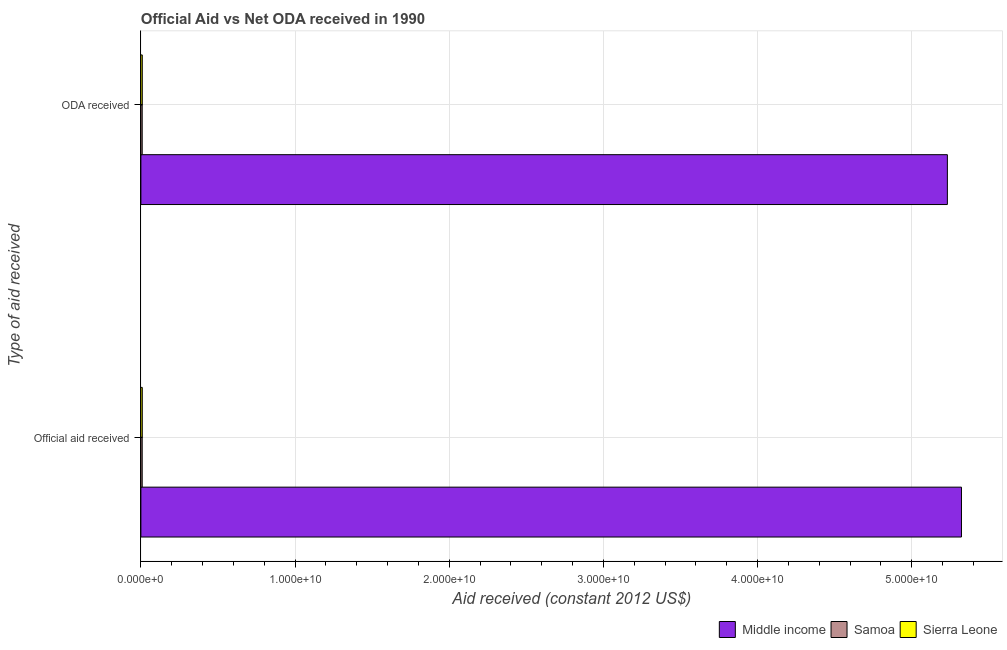How many groups of bars are there?
Give a very brief answer. 2. How many bars are there on the 1st tick from the bottom?
Your answer should be very brief. 3. What is the label of the 2nd group of bars from the top?
Your response must be concise. Official aid received. What is the official aid received in Sierra Leone?
Keep it short and to the point. 9.17e+07. Across all countries, what is the maximum official aid received?
Offer a very short reply. 5.32e+1. Across all countries, what is the minimum official aid received?
Provide a short and direct response. 8.48e+07. In which country was the oda received maximum?
Give a very brief answer. Middle income. In which country was the official aid received minimum?
Your answer should be compact. Samoa. What is the total oda received in the graph?
Provide a short and direct response. 5.25e+1. What is the difference between the oda received in Middle income and that in Samoa?
Your answer should be compact. 5.22e+1. What is the difference between the official aid received in Middle income and the oda received in Samoa?
Ensure brevity in your answer.  5.31e+1. What is the average official aid received per country?
Offer a very short reply. 1.78e+1. What is the difference between the oda received and official aid received in Middle income?
Ensure brevity in your answer.  -9.14e+08. In how many countries, is the official aid received greater than 28000000000 US$?
Keep it short and to the point. 1. What is the ratio of the official aid received in Samoa to that in Middle income?
Make the answer very short. 0. Is the official aid received in Middle income less than that in Samoa?
Provide a succinct answer. No. In how many countries, is the oda received greater than the average oda received taken over all countries?
Offer a very short reply. 1. What does the 3rd bar from the top in ODA received represents?
Make the answer very short. Middle income. What does the 3rd bar from the bottom in Official aid received represents?
Keep it short and to the point. Sierra Leone. What is the difference between two consecutive major ticks on the X-axis?
Your response must be concise. 1.00e+1. Where does the legend appear in the graph?
Your answer should be compact. Bottom right. What is the title of the graph?
Your answer should be compact. Official Aid vs Net ODA received in 1990 . What is the label or title of the X-axis?
Give a very brief answer. Aid received (constant 2012 US$). What is the label or title of the Y-axis?
Your response must be concise. Type of aid received. What is the Aid received (constant 2012 US$) of Middle income in Official aid received?
Make the answer very short. 5.32e+1. What is the Aid received (constant 2012 US$) of Samoa in Official aid received?
Keep it short and to the point. 8.48e+07. What is the Aid received (constant 2012 US$) in Sierra Leone in Official aid received?
Your response must be concise. 9.17e+07. What is the Aid received (constant 2012 US$) in Middle income in ODA received?
Ensure brevity in your answer.  5.23e+1. What is the Aid received (constant 2012 US$) of Samoa in ODA received?
Your answer should be compact. 8.48e+07. What is the Aid received (constant 2012 US$) in Sierra Leone in ODA received?
Make the answer very short. 9.17e+07. Across all Type of aid received, what is the maximum Aid received (constant 2012 US$) of Middle income?
Offer a terse response. 5.32e+1. Across all Type of aid received, what is the maximum Aid received (constant 2012 US$) of Samoa?
Ensure brevity in your answer.  8.48e+07. Across all Type of aid received, what is the maximum Aid received (constant 2012 US$) of Sierra Leone?
Your response must be concise. 9.17e+07. Across all Type of aid received, what is the minimum Aid received (constant 2012 US$) of Middle income?
Keep it short and to the point. 5.23e+1. Across all Type of aid received, what is the minimum Aid received (constant 2012 US$) of Samoa?
Provide a short and direct response. 8.48e+07. Across all Type of aid received, what is the minimum Aid received (constant 2012 US$) of Sierra Leone?
Provide a succinct answer. 9.17e+07. What is the total Aid received (constant 2012 US$) of Middle income in the graph?
Keep it short and to the point. 1.06e+11. What is the total Aid received (constant 2012 US$) of Samoa in the graph?
Your answer should be very brief. 1.70e+08. What is the total Aid received (constant 2012 US$) in Sierra Leone in the graph?
Keep it short and to the point. 1.83e+08. What is the difference between the Aid received (constant 2012 US$) of Middle income in Official aid received and that in ODA received?
Provide a succinct answer. 9.14e+08. What is the difference between the Aid received (constant 2012 US$) in Samoa in Official aid received and that in ODA received?
Your answer should be compact. 0. What is the difference between the Aid received (constant 2012 US$) in Sierra Leone in Official aid received and that in ODA received?
Give a very brief answer. 0. What is the difference between the Aid received (constant 2012 US$) of Middle income in Official aid received and the Aid received (constant 2012 US$) of Samoa in ODA received?
Provide a short and direct response. 5.31e+1. What is the difference between the Aid received (constant 2012 US$) of Middle income in Official aid received and the Aid received (constant 2012 US$) of Sierra Leone in ODA received?
Offer a very short reply. 5.31e+1. What is the difference between the Aid received (constant 2012 US$) in Samoa in Official aid received and the Aid received (constant 2012 US$) in Sierra Leone in ODA received?
Ensure brevity in your answer.  -6.94e+06. What is the average Aid received (constant 2012 US$) in Middle income per Type of aid received?
Keep it short and to the point. 5.28e+1. What is the average Aid received (constant 2012 US$) in Samoa per Type of aid received?
Ensure brevity in your answer.  8.48e+07. What is the average Aid received (constant 2012 US$) of Sierra Leone per Type of aid received?
Your response must be concise. 9.17e+07. What is the difference between the Aid received (constant 2012 US$) in Middle income and Aid received (constant 2012 US$) in Samoa in Official aid received?
Your response must be concise. 5.31e+1. What is the difference between the Aid received (constant 2012 US$) of Middle income and Aid received (constant 2012 US$) of Sierra Leone in Official aid received?
Your response must be concise. 5.31e+1. What is the difference between the Aid received (constant 2012 US$) in Samoa and Aid received (constant 2012 US$) in Sierra Leone in Official aid received?
Ensure brevity in your answer.  -6.94e+06. What is the difference between the Aid received (constant 2012 US$) of Middle income and Aid received (constant 2012 US$) of Samoa in ODA received?
Your answer should be compact. 5.22e+1. What is the difference between the Aid received (constant 2012 US$) of Middle income and Aid received (constant 2012 US$) of Sierra Leone in ODA received?
Offer a terse response. 5.22e+1. What is the difference between the Aid received (constant 2012 US$) of Samoa and Aid received (constant 2012 US$) of Sierra Leone in ODA received?
Your response must be concise. -6.94e+06. What is the ratio of the Aid received (constant 2012 US$) in Middle income in Official aid received to that in ODA received?
Your answer should be compact. 1.02. What is the ratio of the Aid received (constant 2012 US$) of Samoa in Official aid received to that in ODA received?
Your response must be concise. 1. What is the difference between the highest and the second highest Aid received (constant 2012 US$) of Middle income?
Your answer should be very brief. 9.14e+08. What is the difference between the highest and the second highest Aid received (constant 2012 US$) of Samoa?
Your answer should be compact. 0. What is the difference between the highest and the lowest Aid received (constant 2012 US$) in Middle income?
Ensure brevity in your answer.  9.14e+08. What is the difference between the highest and the lowest Aid received (constant 2012 US$) in Samoa?
Keep it short and to the point. 0. What is the difference between the highest and the lowest Aid received (constant 2012 US$) of Sierra Leone?
Offer a terse response. 0. 